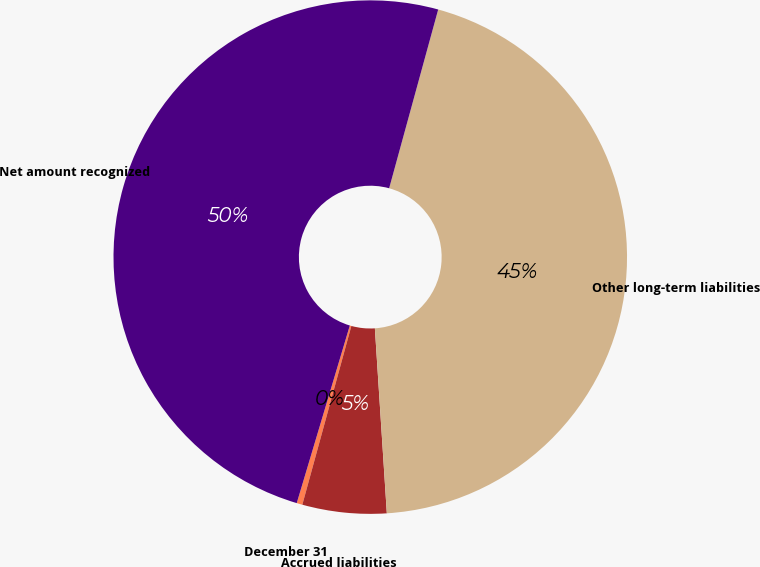Convert chart. <chart><loc_0><loc_0><loc_500><loc_500><pie_chart><fcel>December 31<fcel>Accrued liabilities<fcel>Other long-term liabilities<fcel>Net amount recognized<nl><fcel>0.36%<fcel>5.29%<fcel>44.71%<fcel>49.64%<nl></chart> 